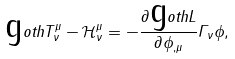Convert formula to latex. <formula><loc_0><loc_0><loc_500><loc_500>\text  goth{T} ^ { \mu } _ { \nu } - \mathcal { H } ^ { \mu } _ { \nu } = - \frac { \partial \text  goth{L} } { \partial \phi _ { , \mu } } \Gamma _ { \nu } \phi ,</formula> 